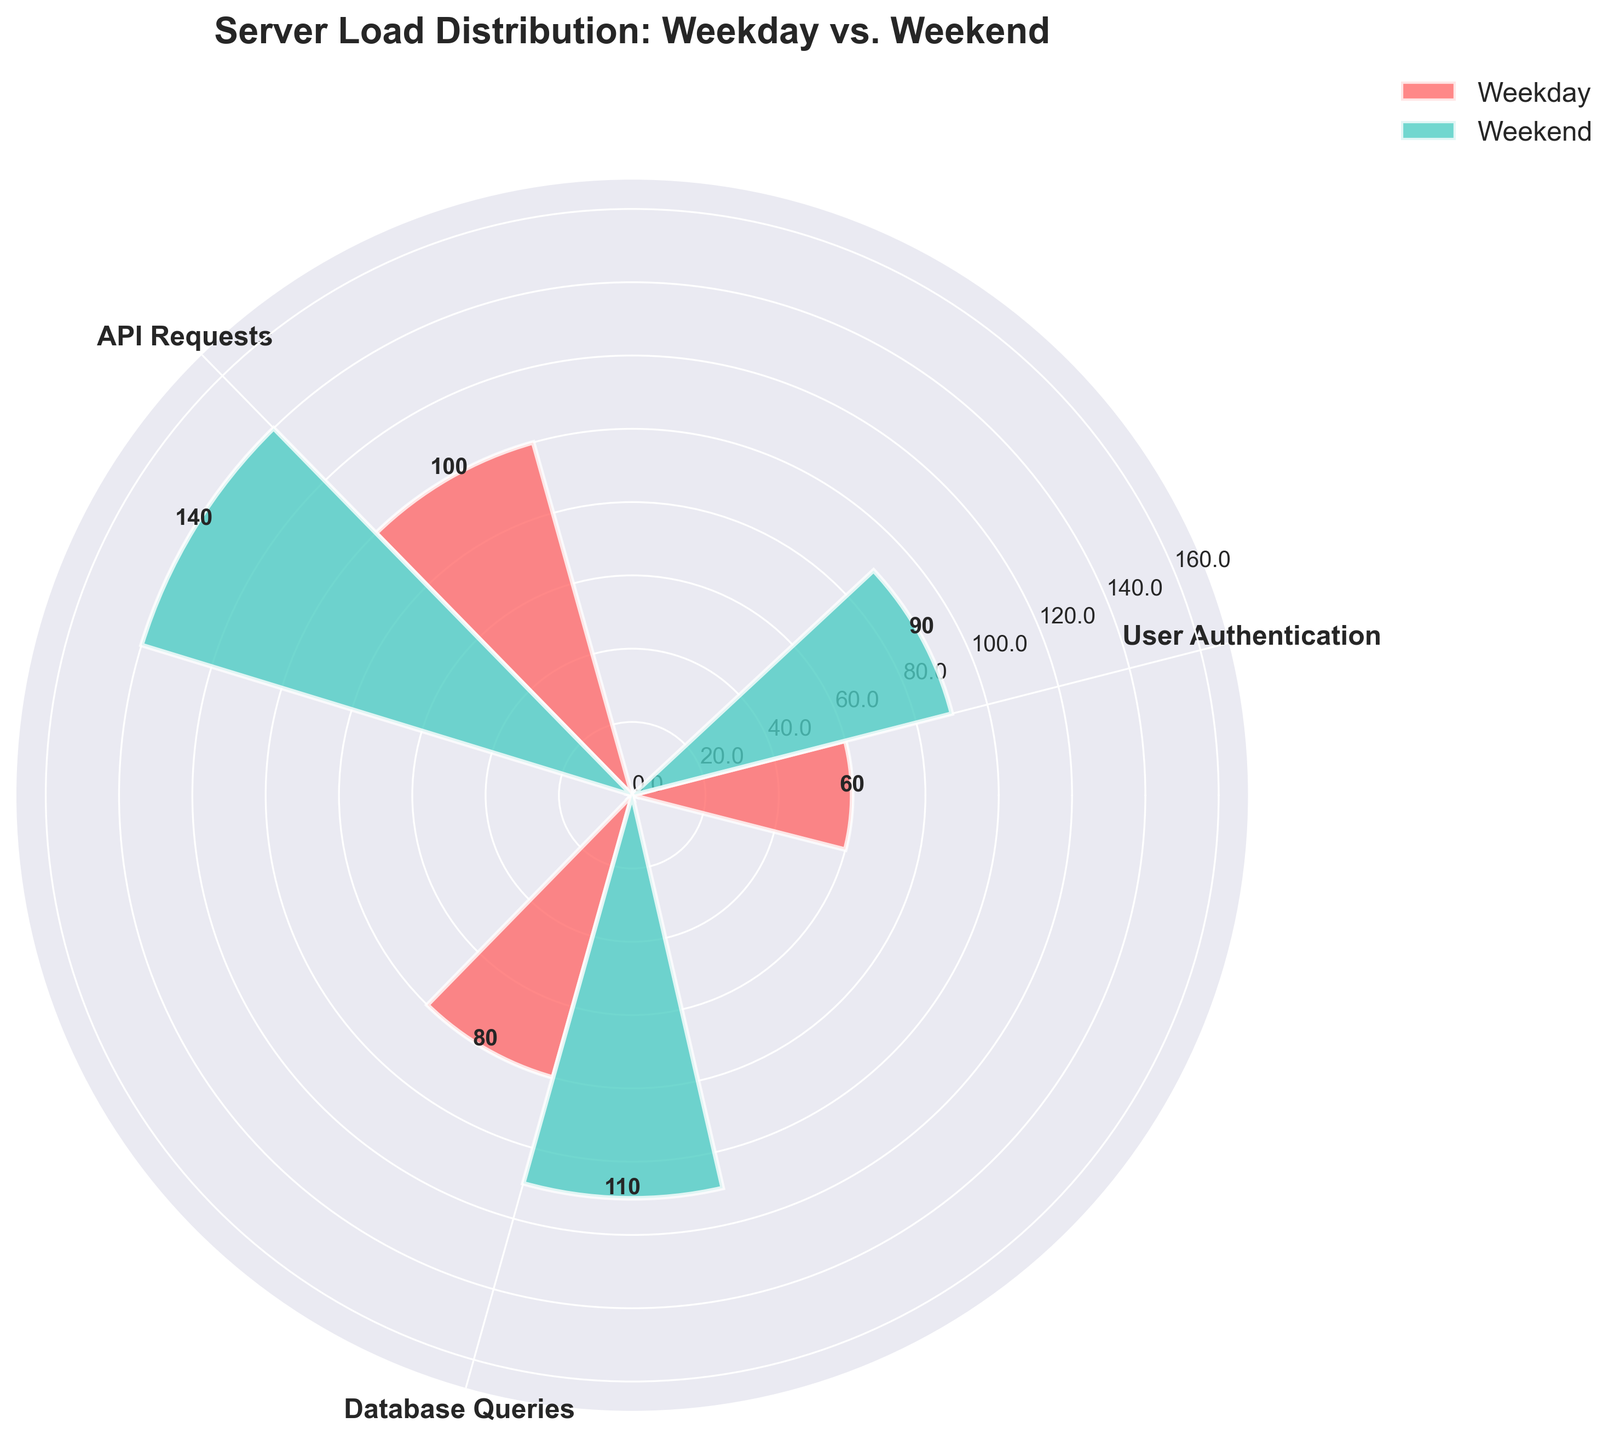what is the title of the chart? The title of the chart is displayed at the top of the figure. It reads "Server Load Distribution: Weekday vs. Weekend."
Answer: Server Load Distribution: Weekday vs. Weekend What are the categories listed in the chart? The categories are listed around the circumference of the polar plot, with each category having its own segment. The categories are "User Authentication," "API Requests," and "Database Queries."
Answer: User Authentication, API Requests, Database Queries Which category has the highest server load on the weekend? To find the category with the highest server load on the weekend, you need to look at the height of the weekend bars (colored in green) and identify the tallest bar. The tallest weekend bar corresponds to "API Requests."
Answer: API Requests What is the total server load for "User Authentication" during both weekdays and weekends? The total server load for "User Authentication" is the sum of the weekday and weekend values. Adding 60 (weekday) and 90 (weekend) gives 150.
Answer: 150 By how much does the server load for "Database Queries" increase from weekdays to weekends? To determine the increase, subtract the weekday load from the weekend load for "Database Queries." Subtract 80 (weekday) from 110 (weekend) to get 30.
Answer: 30 Which has a higher increase in server load from weekday to weekend: "API Requests" or "User Authentication"? Calculate the increase for both categories. "API Requests" increases from 100 to 140, a difference of 40. "User Authentication" increases from 60 to 90, a difference of 30. Therefore, "API Requests" has a higher increase.
Answer: API Requests What is the average server load for "Database Queries" across weekdays and weekends? To find the average, add the weekday and weekend values for "Database Queries" and divide by 2. (80 (weekday) + 110 (weekend)) / 2 = 95.
Answer: 95 Between "User Authentication" and "Database Queries," which has a higher weekday server load? Compare the weekday server loads for the two categories. "Database Queries" has a load of 80, while "User Authentication" has a load of 60. "Database Queries" has a higher load.
Answer: Database Queries What is the difference between the highest and lowest server loads on the weekend? Identify the highest and lowest weekend server loads. The highest is "API Requests" at 140, and the lowest is "User Authentication" at 90. Subtract the lowest from the highest: 140 - 90 = 50.
Answer: 50 